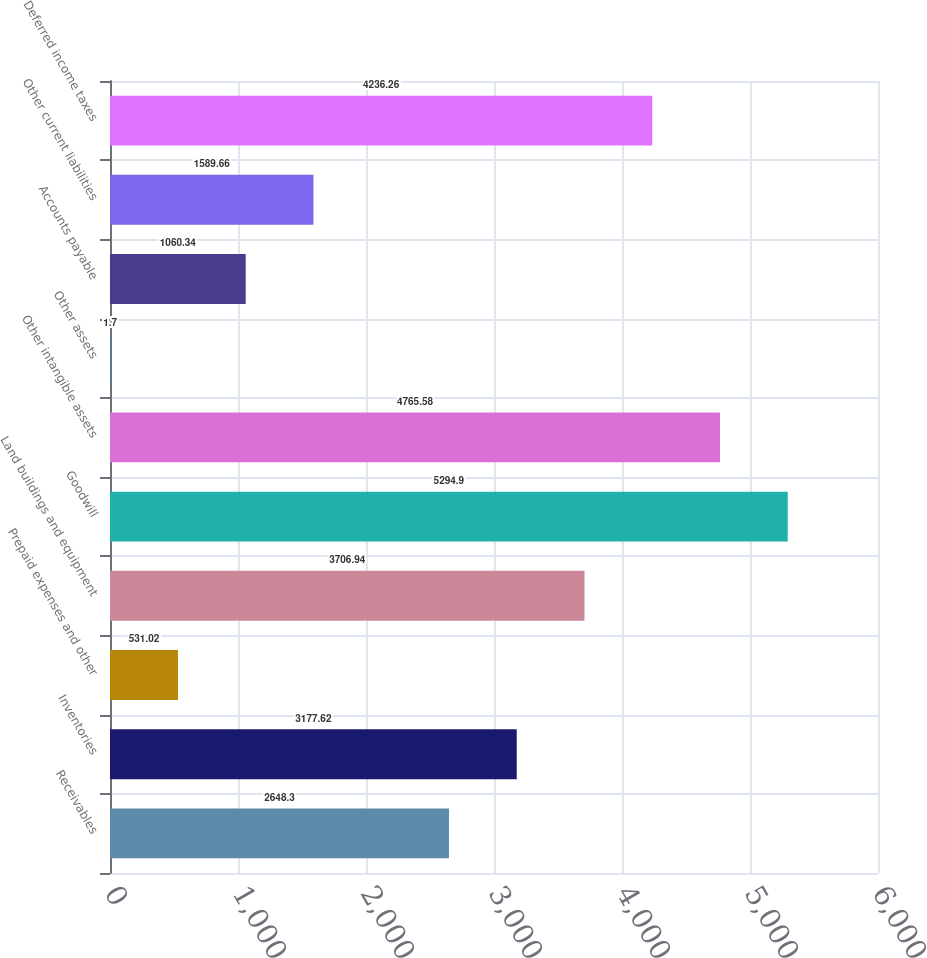Convert chart to OTSL. <chart><loc_0><loc_0><loc_500><loc_500><bar_chart><fcel>Receivables<fcel>Inventories<fcel>Prepaid expenses and other<fcel>Land buildings and equipment<fcel>Goodwill<fcel>Other intangible assets<fcel>Other assets<fcel>Accounts payable<fcel>Other current liabilities<fcel>Deferred income taxes<nl><fcel>2648.3<fcel>3177.62<fcel>531.02<fcel>3706.94<fcel>5294.9<fcel>4765.58<fcel>1.7<fcel>1060.34<fcel>1589.66<fcel>4236.26<nl></chart> 